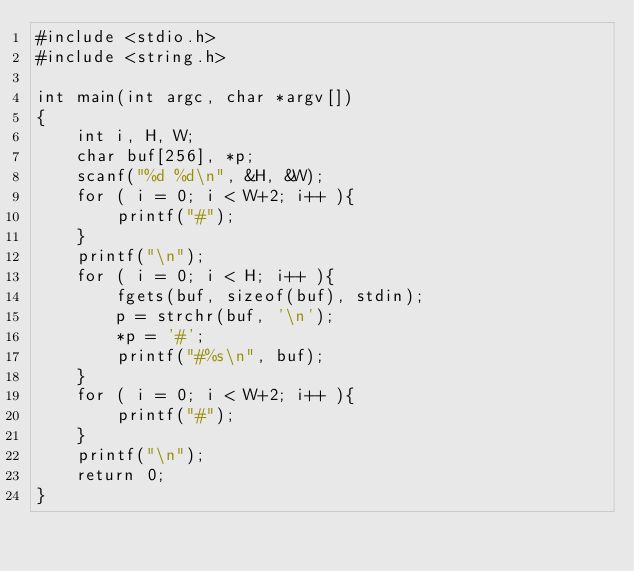Convert code to text. <code><loc_0><loc_0><loc_500><loc_500><_C_>#include <stdio.h>
#include <string.h>

int main(int argc, char *argv[])
{
    int i, H, W;
    char buf[256], *p;
    scanf("%d %d\n", &H, &W);
    for ( i = 0; i < W+2; i++ ){
        printf("#");
    }
    printf("\n");
    for ( i = 0; i < H; i++ ){
        fgets(buf, sizeof(buf), stdin);
        p = strchr(buf, '\n');
        *p = '#';
        printf("#%s\n", buf);
    }
    for ( i = 0; i < W+2; i++ ){
        printf("#");
    }
    printf("\n");
    return 0;
}</code> 